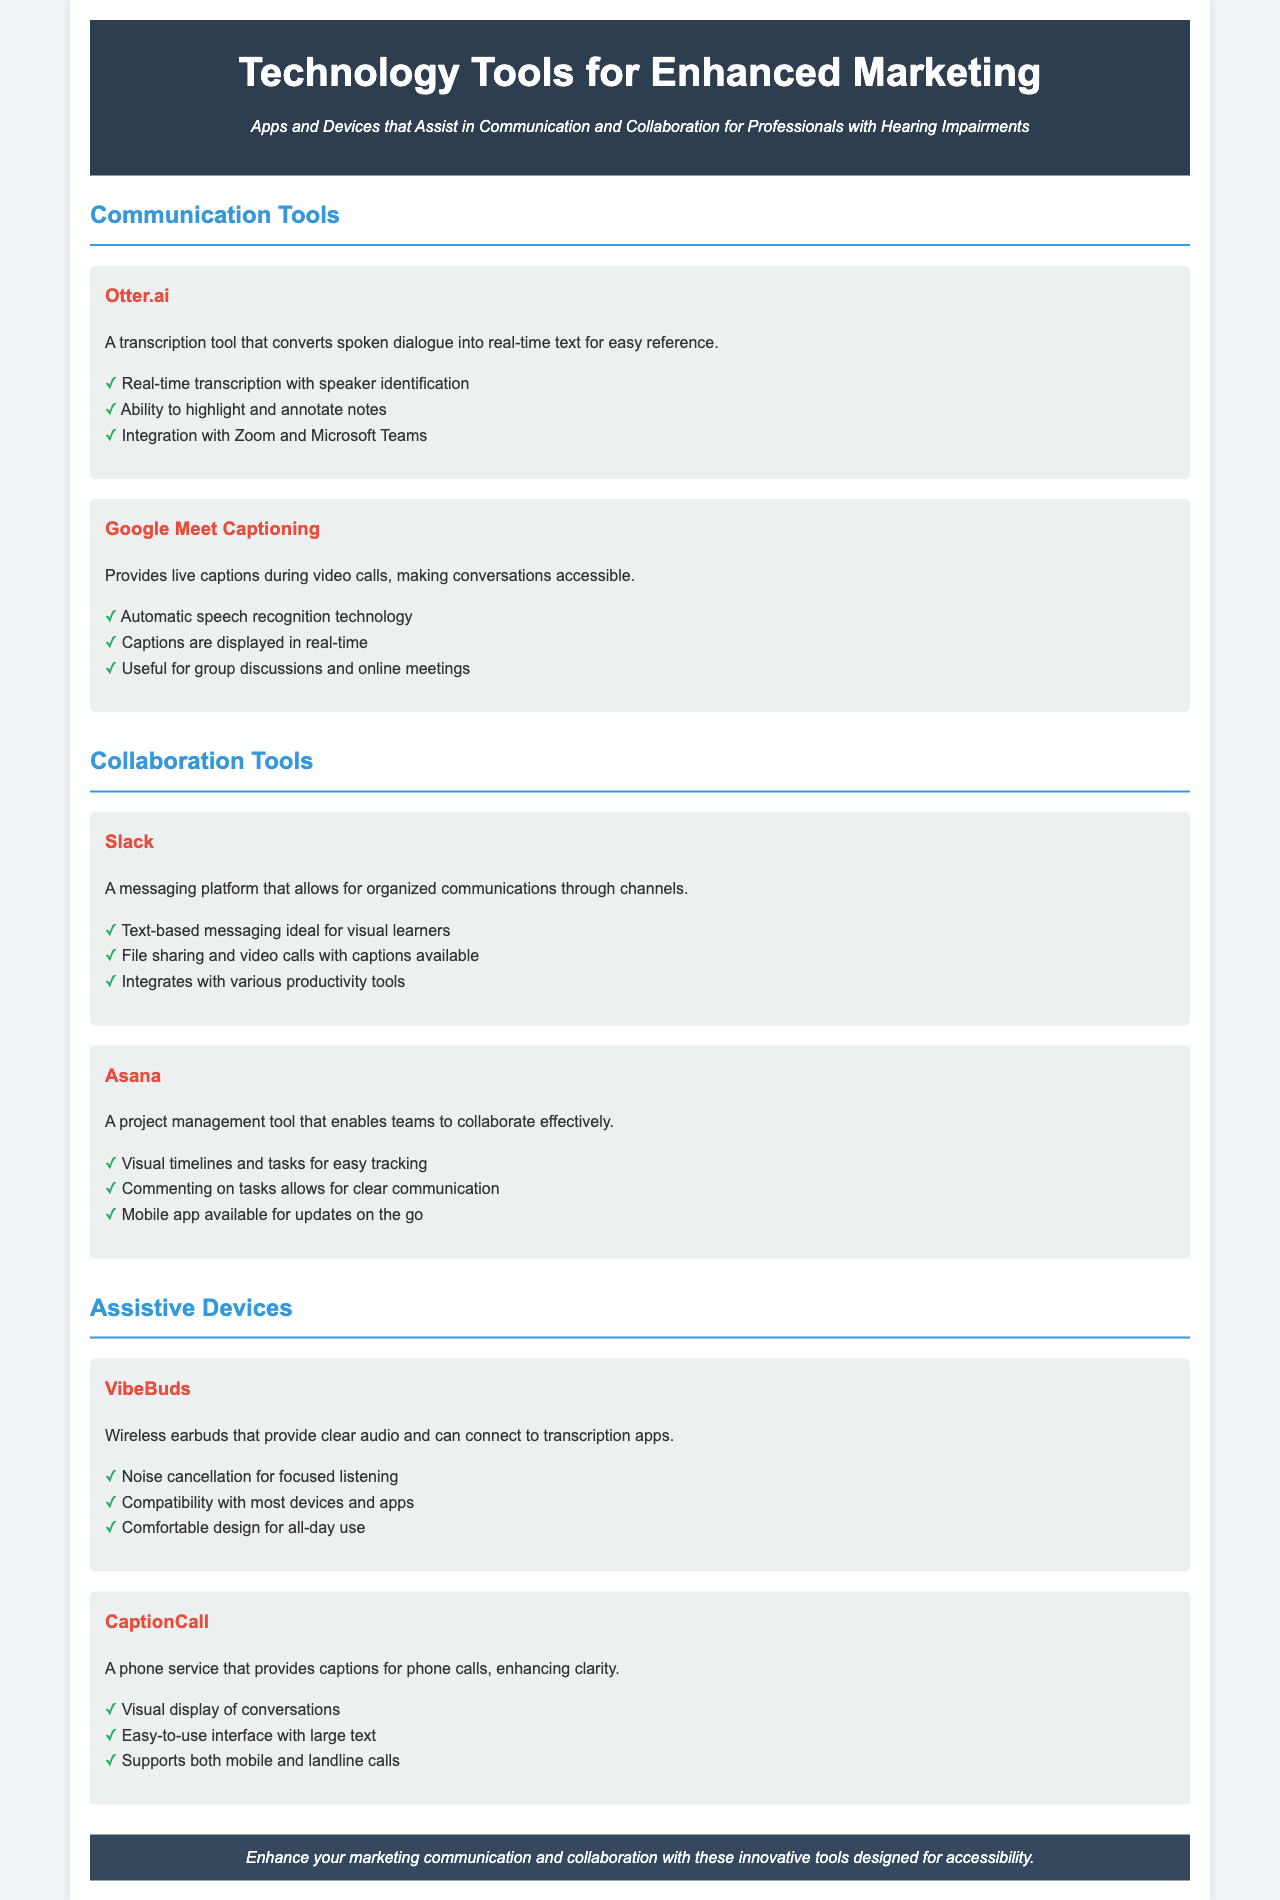What is the title of the brochure? The title is a key identifier of the document, providing insight into the content.
Answer: Technology Tools for Enhanced Marketing What is the purpose of Google Meet Captioning? This tool is designed specifically to enhance accessibility during video calls.
Answer: Provides live captions during video calls Which tool offers real-time transcription? A specific feature of a communication tool is its ability to convert dialogue into text.
Answer: Otter.ai What is a primary feature of Slack? Understanding the primary capabilities of Slack can highlight its usefulness for communication.
Answer: Text-based messaging ideal for visual learners What assistive device offers noise cancellation? This relates to features of tools that improve audio experience for hearing-impaired users.
Answer: VibeBuds How many communication tools are listed in the document? The count of tools in a specific category helps assess the options available.
Answer: Two What color is used for the heading section? Identifying the color scheme provides an overview of the document style.
Answer: Dark blue What type of application is Asana? Knowing the category of the tool helps in understanding its specific function in marketing.
Answer: Project management tool What does CaptionCall provide during phone calls? This explains the basic function of a device aimed at improving clarity in communication.
Answer: Captions for phone calls 